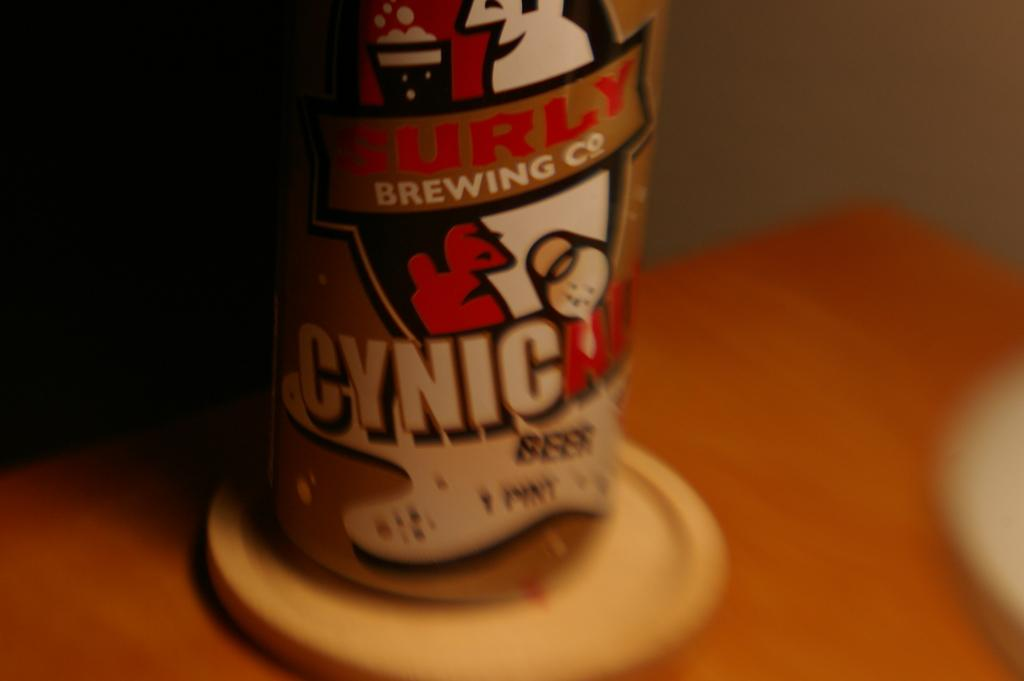Provide a one-sentence caption for the provided image. A pint of beer from the Surly Brewing Company. 